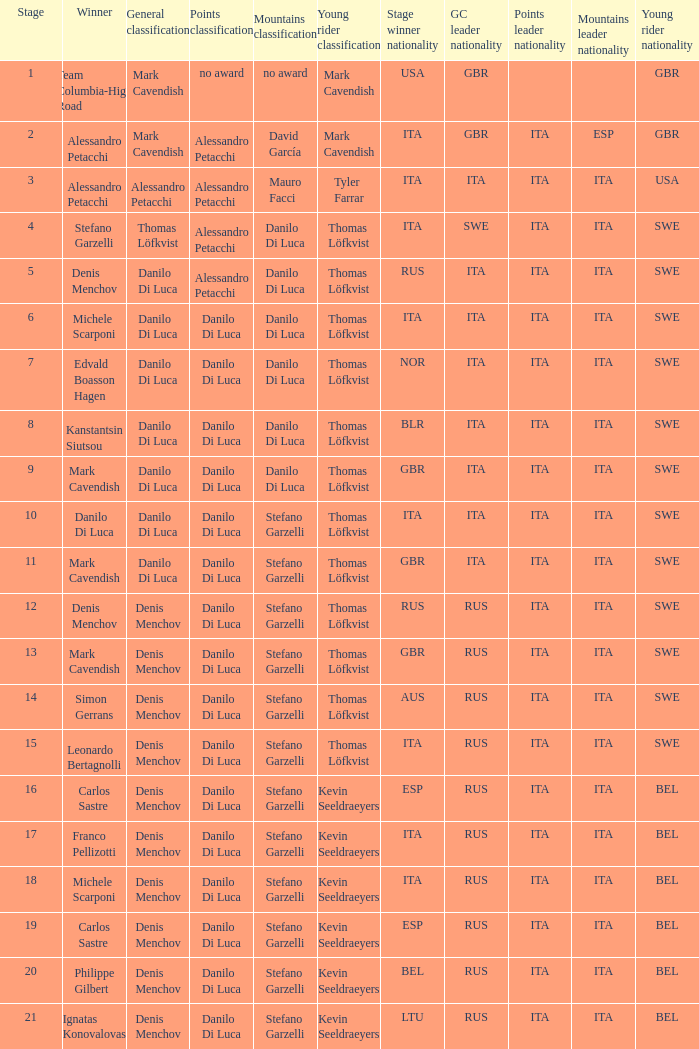When philippe gilbert is the winner who is the points classification? Danilo Di Luca. 